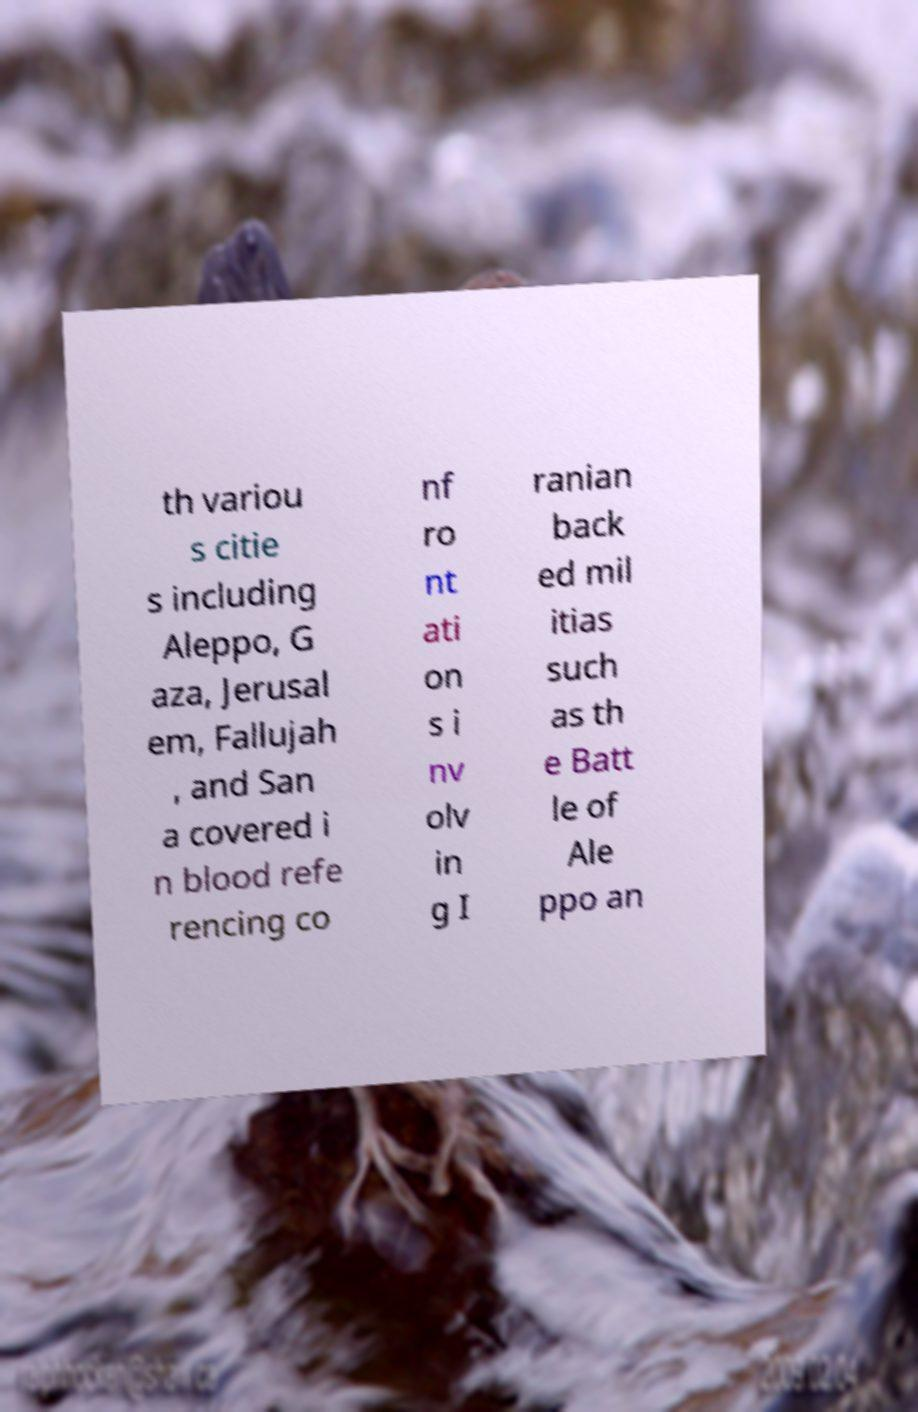Could you assist in decoding the text presented in this image and type it out clearly? th variou s citie s including Aleppo, G aza, Jerusal em, Fallujah , and San a covered i n blood refe rencing co nf ro nt ati on s i nv olv in g I ranian back ed mil itias such as th e Batt le of Ale ppo an 